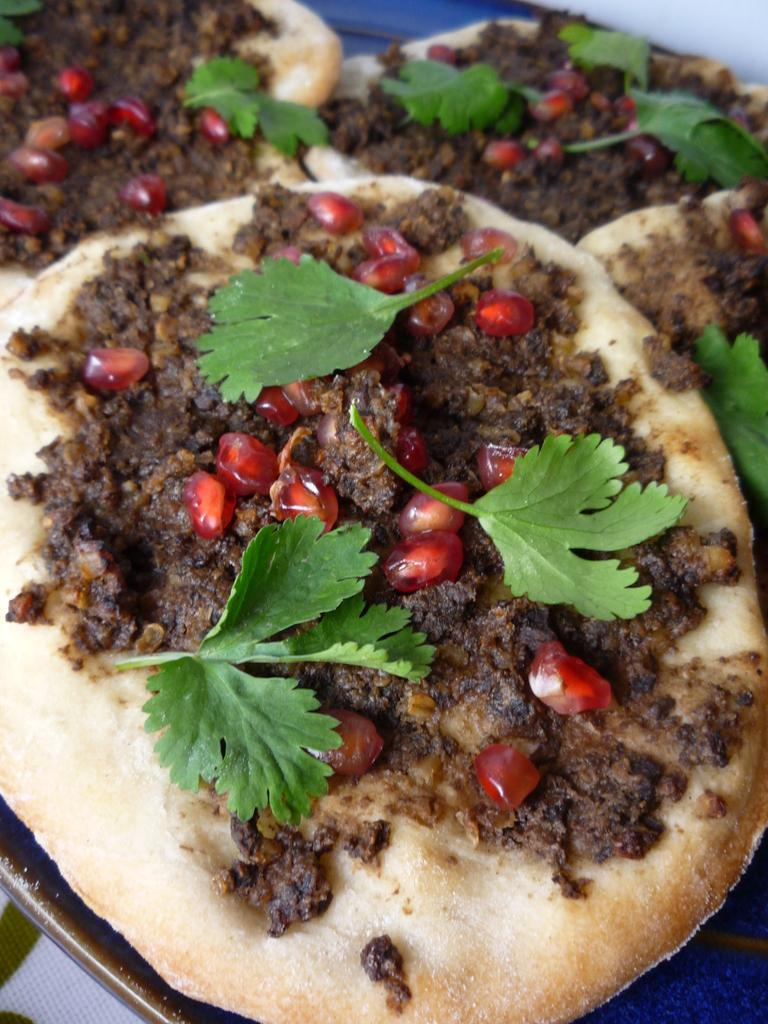What can be seen in the image? There is food visible in the image. Can you describe the sneeze of the person eating the cheese in the image? There is no person eating cheese in the image, nor is there any sneeze depicted. 